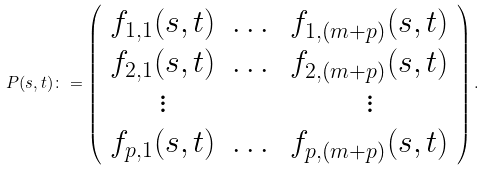<formula> <loc_0><loc_0><loc_500><loc_500>P ( s , t ) \colon = \left ( \begin{array} { c c c } f _ { 1 , 1 } ( s , t ) & \dots & f _ { 1 , ( m + p ) } ( s , t ) \\ f _ { 2 , 1 } ( s , t ) & \dots & f _ { 2 , ( m + p ) } ( s , t ) \\ \vdots & & \vdots \\ f _ { p , 1 } ( s , t ) & \dots & f _ { p , ( m + p ) } ( s , t ) \end{array} \right ) .</formula> 